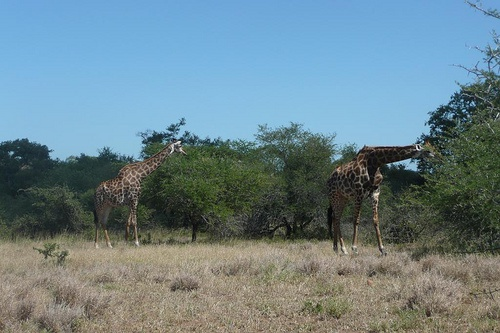Describe the objects in this image and their specific colors. I can see giraffe in lightblue, black, and gray tones and giraffe in lightblue, gray, black, and darkgray tones in this image. 